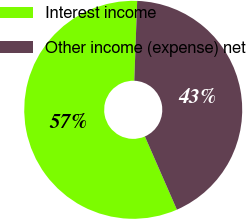Convert chart to OTSL. <chart><loc_0><loc_0><loc_500><loc_500><pie_chart><fcel>Interest income<fcel>Other income (expense) net<nl><fcel>57.14%<fcel>42.86%<nl></chart> 